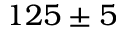<formula> <loc_0><loc_0><loc_500><loc_500>1 2 5 \pm 5</formula> 